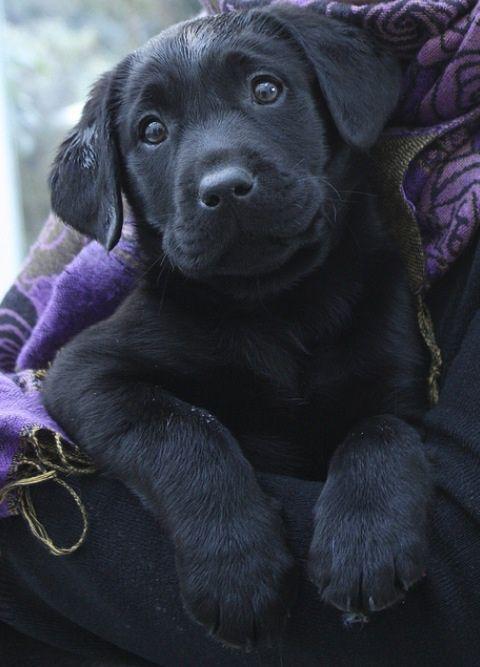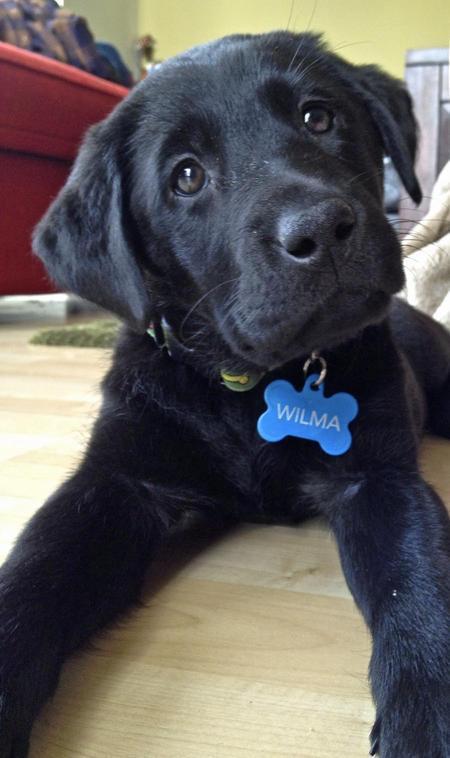The first image is the image on the left, the second image is the image on the right. Analyze the images presented: Is the assertion "there is a puppy with tags on it's collar" valid? Answer yes or no. Yes. The first image is the image on the left, the second image is the image on the right. For the images displayed, is the sentence "Each image shows a black lab pup in a sitting pose." factually correct? Answer yes or no. No. 